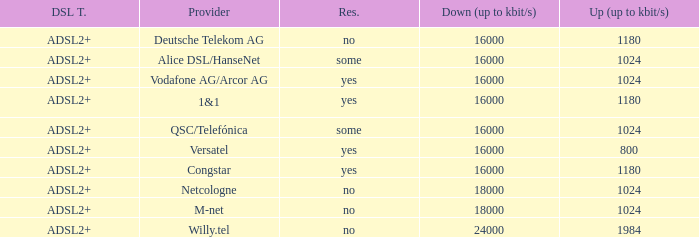How many providers are there where the resale category is yes and bandwith is up is 1024? 1.0. 